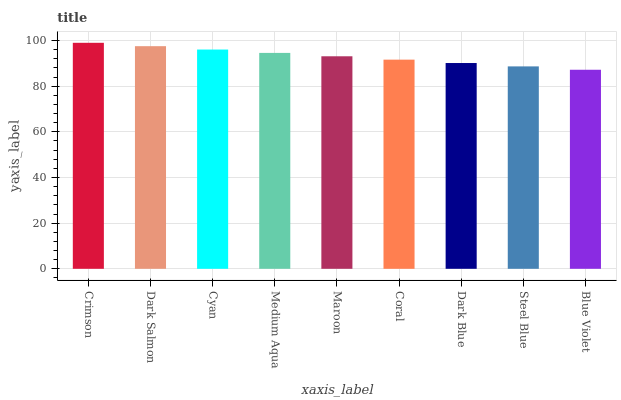Is Blue Violet the minimum?
Answer yes or no. Yes. Is Crimson the maximum?
Answer yes or no. Yes. Is Dark Salmon the minimum?
Answer yes or no. No. Is Dark Salmon the maximum?
Answer yes or no. No. Is Crimson greater than Dark Salmon?
Answer yes or no. Yes. Is Dark Salmon less than Crimson?
Answer yes or no. Yes. Is Dark Salmon greater than Crimson?
Answer yes or no. No. Is Crimson less than Dark Salmon?
Answer yes or no. No. Is Maroon the high median?
Answer yes or no. Yes. Is Maroon the low median?
Answer yes or no. Yes. Is Blue Violet the high median?
Answer yes or no. No. Is Coral the low median?
Answer yes or no. No. 